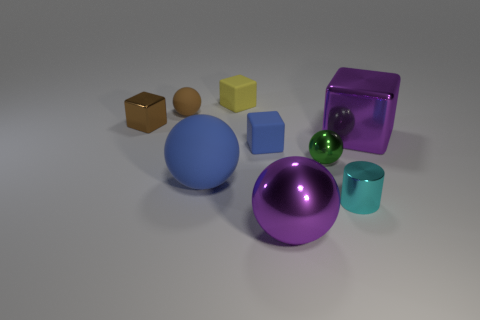Do the large metal thing that is on the left side of the tiny cyan cylinder and the matte thing that is left of the big blue matte sphere have the same shape?
Your answer should be very brief. Yes. Are there any large things that have the same material as the big purple cube?
Provide a short and direct response. Yes. The sphere behind the purple metallic object behind the blue thing that is in front of the small blue thing is what color?
Your answer should be compact. Brown. Is the material of the small sphere that is to the left of the tiny green ball the same as the purple thing in front of the small blue rubber cube?
Ensure brevity in your answer.  No. What shape is the big purple object that is to the right of the shiny cylinder?
Offer a terse response. Cube. What number of things are either purple metallic spheres or big balls behind the cyan metal object?
Your response must be concise. 2. Is the big purple ball made of the same material as the yellow block?
Give a very brief answer. No. Is the number of large metallic balls right of the large block the same as the number of small brown cubes in front of the big blue rubber thing?
Keep it short and to the point. Yes. What number of tiny green metal spheres are on the right side of the big purple metallic ball?
Provide a short and direct response. 1. How many objects are small purple matte cubes or blocks?
Your answer should be compact. 4. 